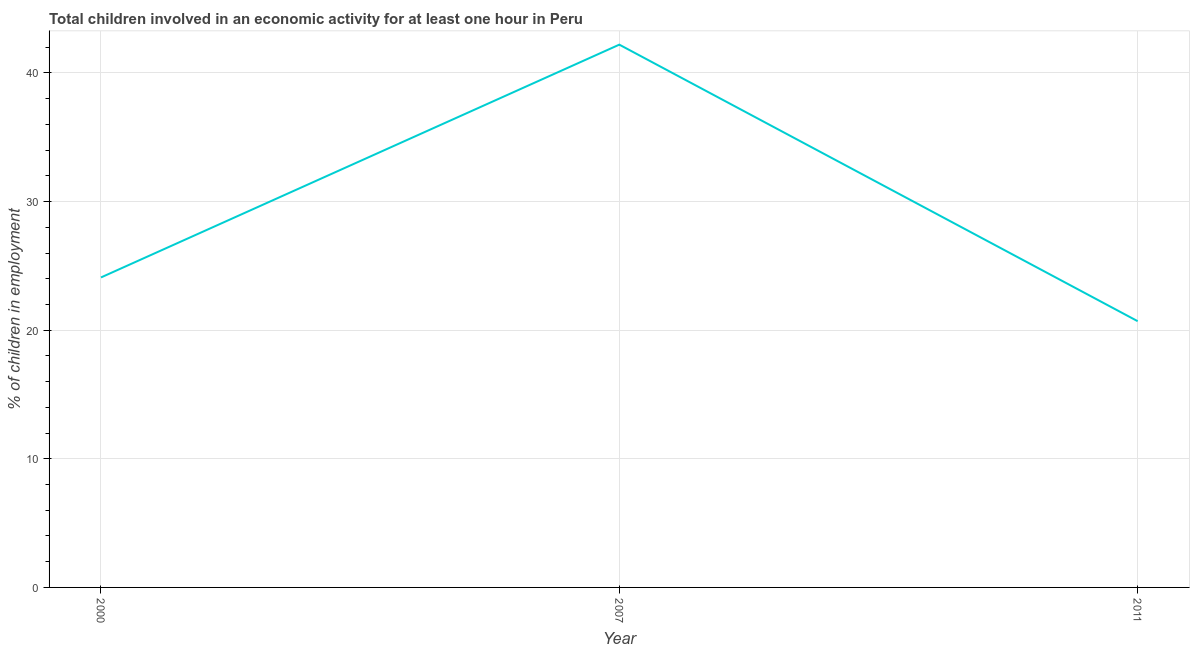What is the percentage of children in employment in 2007?
Offer a very short reply. 42.2. Across all years, what is the maximum percentage of children in employment?
Give a very brief answer. 42.2. Across all years, what is the minimum percentage of children in employment?
Provide a succinct answer. 20.7. What is the sum of the percentage of children in employment?
Keep it short and to the point. 87. What is the difference between the percentage of children in employment in 2000 and 2007?
Keep it short and to the point. -18.1. What is the average percentage of children in employment per year?
Keep it short and to the point. 29. What is the median percentage of children in employment?
Make the answer very short. 24.1. What is the ratio of the percentage of children in employment in 2000 to that in 2011?
Your response must be concise. 1.16. Is the percentage of children in employment in 2000 less than that in 2011?
Ensure brevity in your answer.  No. What is the difference between the highest and the second highest percentage of children in employment?
Offer a terse response. 18.1. Is the sum of the percentage of children in employment in 2007 and 2011 greater than the maximum percentage of children in employment across all years?
Your response must be concise. Yes. What is the difference between the highest and the lowest percentage of children in employment?
Provide a short and direct response. 21.5. Are the values on the major ticks of Y-axis written in scientific E-notation?
Keep it short and to the point. No. Does the graph contain grids?
Give a very brief answer. Yes. What is the title of the graph?
Your answer should be compact. Total children involved in an economic activity for at least one hour in Peru. What is the label or title of the Y-axis?
Your answer should be compact. % of children in employment. What is the % of children in employment of 2000?
Your answer should be compact. 24.1. What is the % of children in employment of 2007?
Your answer should be very brief. 42.2. What is the % of children in employment of 2011?
Make the answer very short. 20.7. What is the difference between the % of children in employment in 2000 and 2007?
Give a very brief answer. -18.1. What is the ratio of the % of children in employment in 2000 to that in 2007?
Your answer should be compact. 0.57. What is the ratio of the % of children in employment in 2000 to that in 2011?
Keep it short and to the point. 1.16. What is the ratio of the % of children in employment in 2007 to that in 2011?
Offer a terse response. 2.04. 